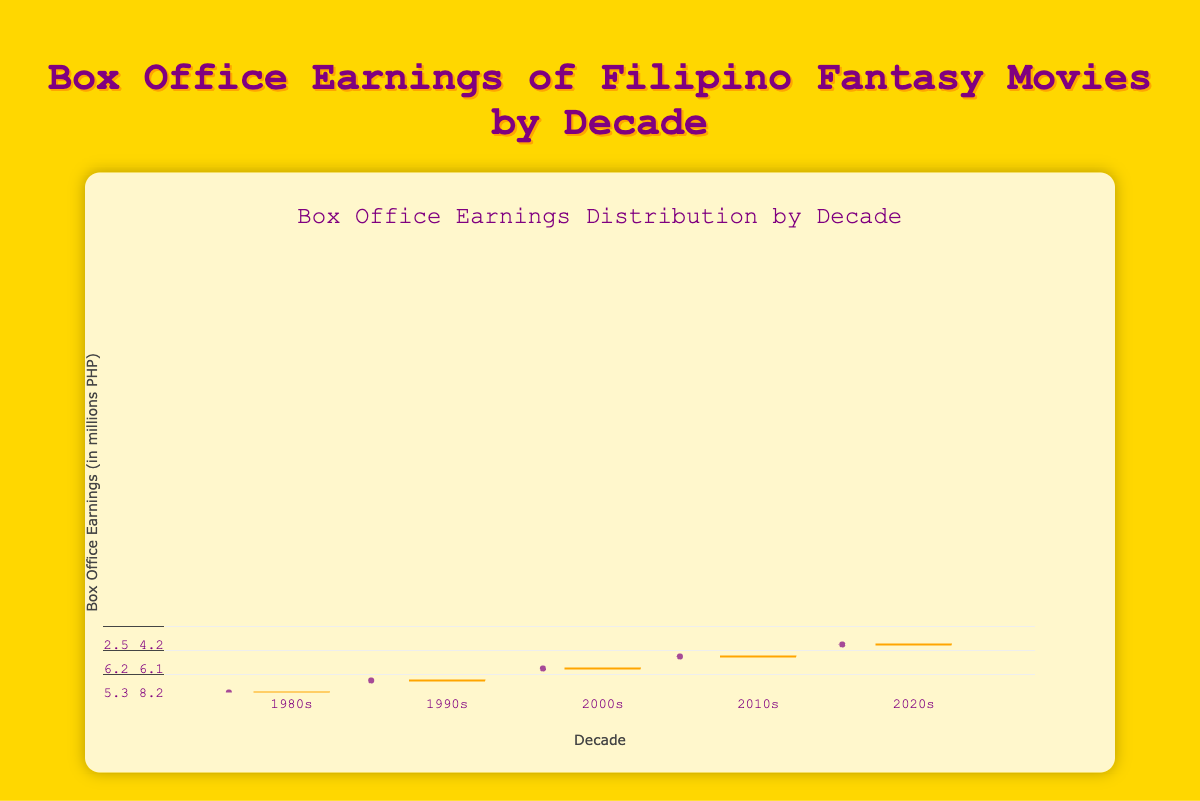Which decade has the highest median box office earnings? The 2010s shows a higher median box office earnings compared to other decades when looking at the central value within the box.
Answer: The 2010s What is the range of box office earnings for movies in the 1980s? The lowest box office earnings in the 1980s is around 2.5 million PHP, and the highest is around 6.2 million PHP. The range is therefore 6.2 - 2.5 = 3.7 million PHP.
Answer: 3.7 million PHP Which individual movie had the highest box office earnings? By examination of the individual points, "Si Agimat at si Enteng Kabisote" in the 2010s is the highest with 31.2 million PHP.
Answer: Si Agimat at si Enteng Kabisote Which decade shows the most variability in box office earnings? Variability can be observed by looking at the spread of the data points. The 2000s have a wider range of earnings from around 8.9 million PHP to 25.8 million PHP compared to other decades.
Answer: The 2000s How do the earnings of the movie "Feng Shui 2" compare to the median earnings of the 2010s? "Feng Shui 2" earned 22.5 million PHP, which is above the median value (the middle line in the box) of the 2010s, making it higher than most movies of its decade.
Answer: Above median Which decade shows the highest minimum box office earnings? The minimum of the box is the smaller whisker. The 2010s have the highest minimum earnings at around 13.9 million PHP.
Answer: The 2010s What can you infer about the box office earnings trend over the decades? The box office earnings show a general increasing trend, peaking in the 2010s and slightly reducing in the 2020s, as seen from the medians and the overall distribution shift upward.
Answer: Increasing trend with a peak in 2010s Among all decades, which decade has the lowest maximum box office earnings? The lowest maximum box office earnings are in the 1980s with around 6.2 million PHP, as seen from the upper whiskers of the boxes.
Answer: The 1980s 